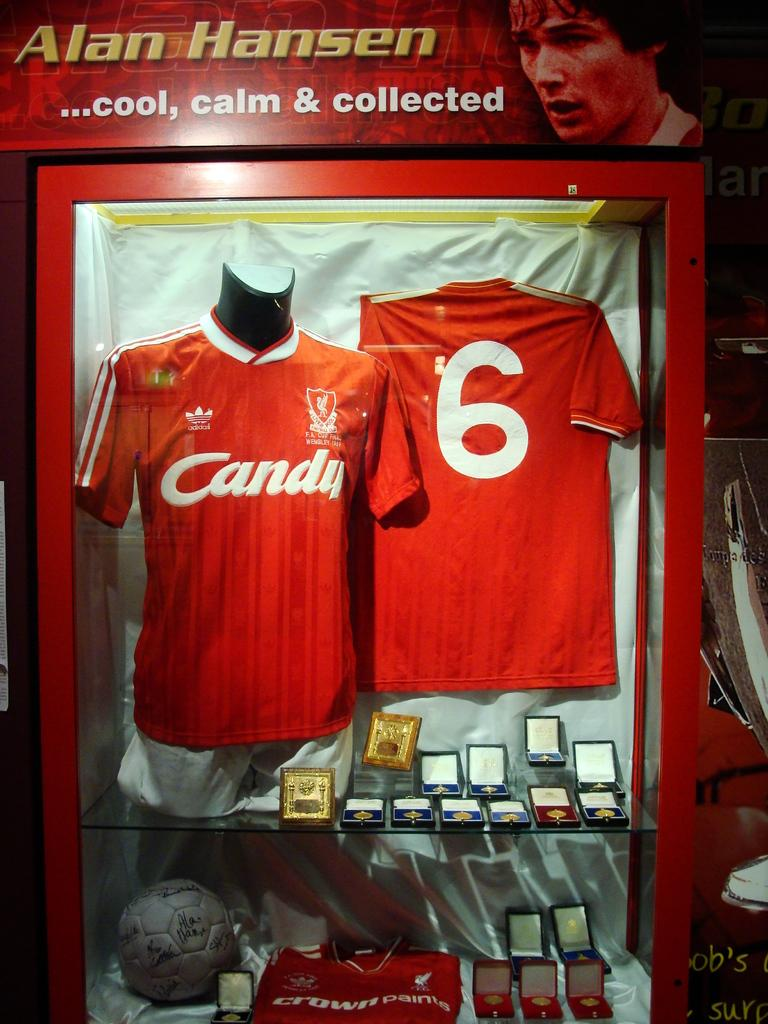<image>
Share a concise interpretation of the image provided. the number 6 on the back of a jersey for someone 